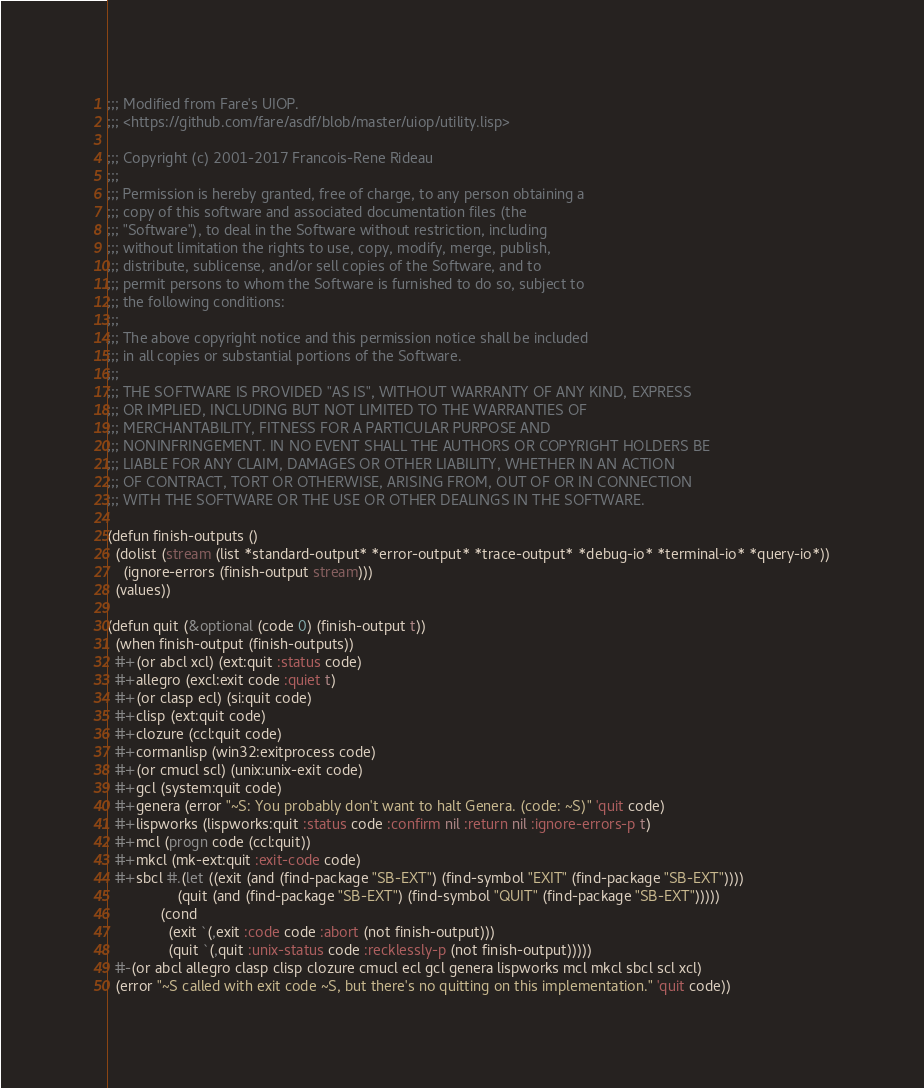Convert code to text. <code><loc_0><loc_0><loc_500><loc_500><_Lisp_>;;; Modified from Fare's UIOP.
;;; <https://github.com/fare/asdf/blob/master/uiop/utility.lisp>

;;; Copyright (c) 2001-2017 Francois-Rene Rideau
;;;
;;; Permission is hereby granted, free of charge, to any person obtaining a
;;; copy of this software and associated documentation files (the
;;; "Software"), to deal in the Software without restriction, including
;;; without limitation the rights to use, copy, modify, merge, publish,
;;; distribute, sublicense, and/or sell copies of the Software, and to
;;; permit persons to whom the Software is furnished to do so, subject to
;;; the following conditions:
;;;
;;; The above copyright notice and this permission notice shall be included
;;; in all copies or substantial portions of the Software.
;;;
;;; THE SOFTWARE IS PROVIDED "AS IS", WITHOUT WARRANTY OF ANY KIND, EXPRESS
;;; OR IMPLIED, INCLUDING BUT NOT LIMITED TO THE WARRANTIES OF
;;; MERCHANTABILITY, FITNESS FOR A PARTICULAR PURPOSE AND
;;; NONINFRINGEMENT. IN NO EVENT SHALL THE AUTHORS OR COPYRIGHT HOLDERS BE
;;; LIABLE FOR ANY CLAIM, DAMAGES OR OTHER LIABILITY, WHETHER IN AN ACTION
;;; OF CONTRACT, TORT OR OTHERWISE, ARISING FROM, OUT OF OR IN CONNECTION
;;; WITH THE SOFTWARE OR THE USE OR OTHER DEALINGS IN THE SOFTWARE.

(defun finish-outputs ()
  (dolist (stream (list *standard-output* *error-output* *trace-output* *debug-io* *terminal-io* *query-io*))
    (ignore-errors (finish-output stream)))
  (values))

(defun quit (&optional (code 0) (finish-output t))
  (when finish-output (finish-outputs))
  #+(or abcl xcl) (ext:quit :status code)
  #+allegro (excl:exit code :quiet t)
  #+(or clasp ecl) (si:quit code)
  #+clisp (ext:quit code)
  #+clozure (ccl:quit code)
  #+cormanlisp (win32:exitprocess code)
  #+(or cmucl scl) (unix:unix-exit code)
  #+gcl (system:quit code)
  #+genera (error "~S: You probably don't want to halt Genera. (code: ~S)" 'quit code)
  #+lispworks (lispworks:quit :status code :confirm nil :return nil :ignore-errors-p t)
  #+mcl (progn code (ccl:quit))
  #+mkcl (mk-ext:quit :exit-code code)
  #+sbcl #.(let ((exit (and (find-package "SB-EXT") (find-symbol "EXIT" (find-package "SB-EXT"))))
                 (quit (and (find-package "SB-EXT") (find-symbol "QUIT" (find-package "SB-EXT")))))
             (cond
               (exit `(,exit :code code :abort (not finish-output)))
               (quit `(,quit :unix-status code :recklessly-p (not finish-output)))))
  #-(or abcl allegro clasp clisp clozure cmucl ecl gcl genera lispworks mcl mkcl sbcl scl xcl)
  (error "~S called with exit code ~S, but there's no quitting on this implementation." 'quit code))
</code> 